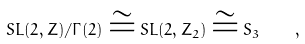Convert formula to latex. <formula><loc_0><loc_0><loc_500><loc_500>S L ( 2 , { Z } ) / \Gamma ( 2 ) \cong S L ( 2 , { Z } _ { 2 } ) \cong S _ { 3 } \quad ,</formula> 